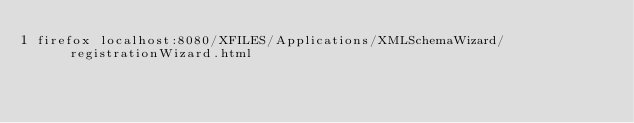Convert code to text. <code><loc_0><loc_0><loc_500><loc_500><_Bash_>firefox localhost:8080/XFILES/Applications/XMLSchemaWizard/registrationWizard.html
</code> 